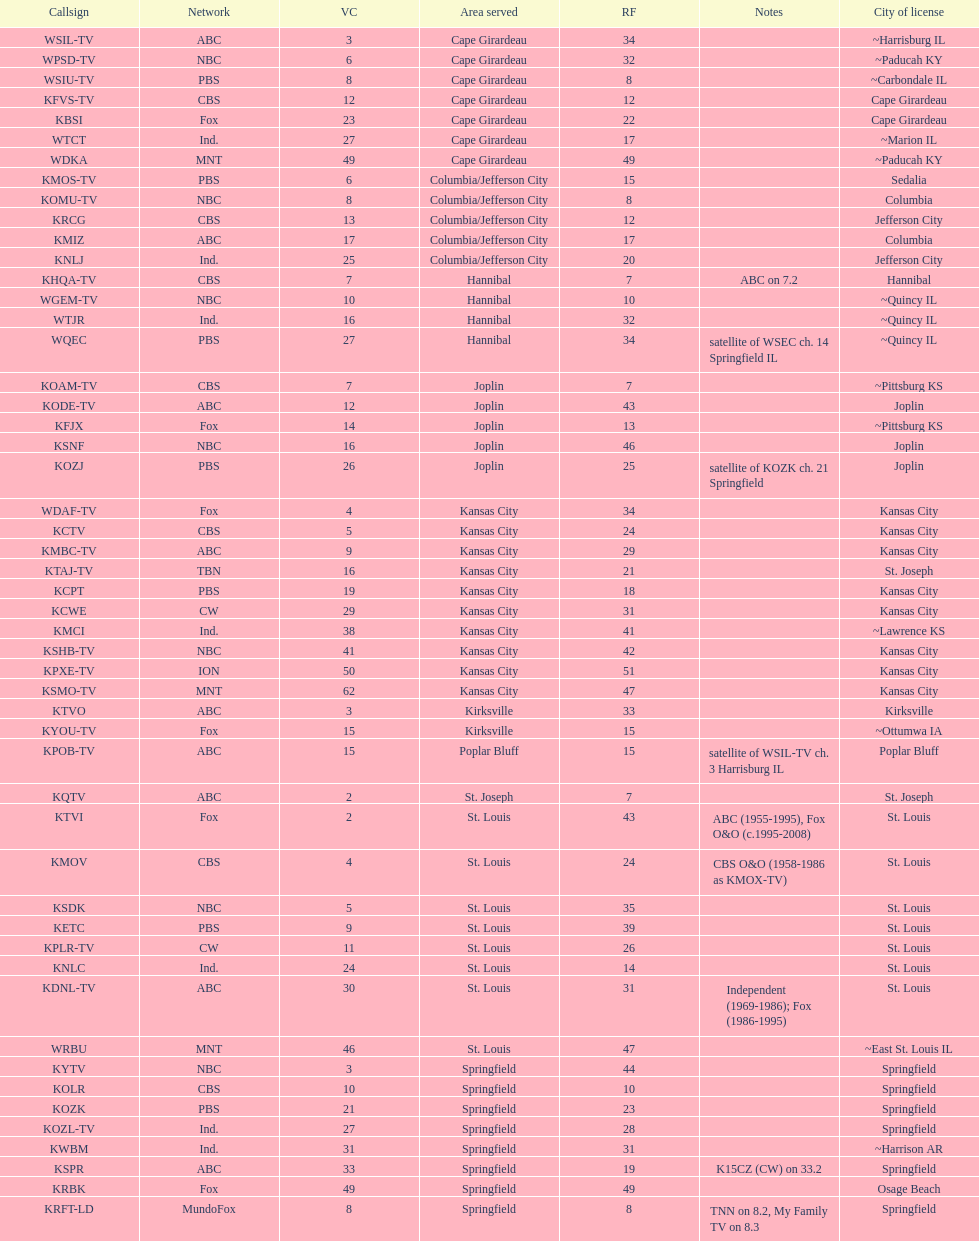What is the total number of stations under the cbs network? 7. 